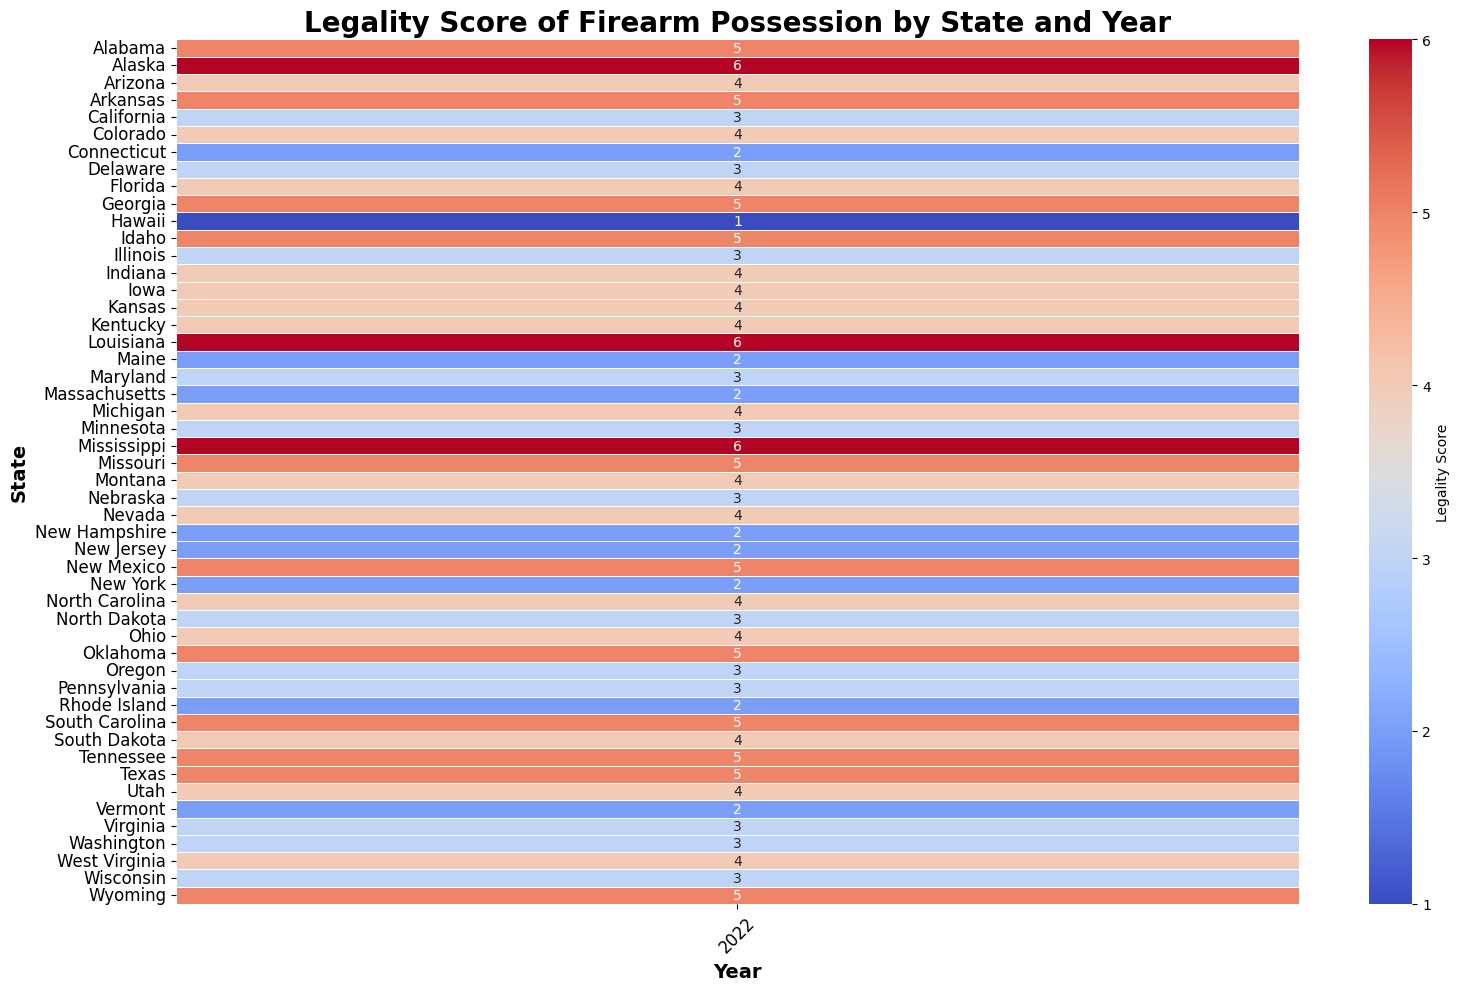What's the highest legality score observed in the heatmap? Identify the highest value in the heatmap labeled 'Legality Score'. The highest score appears to be 6 in states like Alaska, Louisiana, and Mississippi in the year 2022.
Answer: 6 Which state has the lowest crime rate and what is its legality score? Locate the state with the lowest crime rate in reference data and find its corresponding Legality Score in the heatmap. Maine has the lowest crime rate of 138, and its legality score is 2 in 2022.
Answer: Maine, 2 Are there more states with higher legality scores (greater than 4) or lower legality scores (4 or less) in 2022? Count the number of states with legality scores greater than 4 and compare with those having scores 4 or less. In 2022, there are 19 states with scores greater than 4 and 31 states with scores of 4 or less.
Answer: More states have legality scores of 4 or less What is the average legality score for states with crime rates above 500? Identify states with crime rates above 500 from the reference data, then calculate their average legality score from the heatmap. These states are Alaska, Louisiana, Nevada, New Mexico, and Tennessee. Their scores are 6, 6, 4, 5, and 5, respectively. The average is (6 + 6 + 4 + 5 + 5)/5 = 5.2.
Answer: 5.2 Which states have the same legality score of 3 in 2022, and what are their respective crime rates? Identify states with a legality score of 3 from the heatmap and cross-reference with the crime rate data. The states are California, Delaware, Illinois, Maryland, Massachusetts, Minnesota, Nebraska, New Jersey, New York, and Wisconsin. Their respective crime rates are 447, 577, 658, 560, 308, 236, 235, 293, 352, and 320.
Answer: California (447), Delaware (577), Illinois (658), Maryland (560), Massachusetts (308), Minnesota (236), Nebraska (235), New Jersey (293), New York (352), Wisconsin (320) Is there a correlation between the legality score and crime rate? To answer this, observe the pattern in the heatmap and reference data to see if higher crime rates correspond to higher or lower legality scores. Generally, there is no clear visual correlation; both high and low crime rates are seen across various legality scores.
Answer: No clear correlation Which state with a legality score of 5 has the highest crime rate? Among states with a legality score of 5, identify and compare crime rates. States with a legality score of 5 are Alabama, Arkansas, Georgia, Idaho, Mississippi, Missouri, New Mexico, Oklahoma, South Carolina, Tennessee, Texas, and Wyoming. Mississippi has the highest crime rate of 656.
Answer: Mississippi How many states have legality scores of 4 and what are their crime rates? Count the states with legality scores of 4 from the heatmap and list their crime rates. There are 15 such states: Arizona (395), Colorado (505), Florida (384), Indiana (402), Iowa (291), Kansas (398), Kentucky (326), Nevada (818), North Carolina (379), Ohio (379), South Dakota (180), Utah (246), Virginia (212), West Virginia (364), Michigan (438).
Answer: 15; Crime rates: 395, 505, 384, 402, 291, 398, 326, 818, 379, 379, 180, 246, 212, 364, 438 